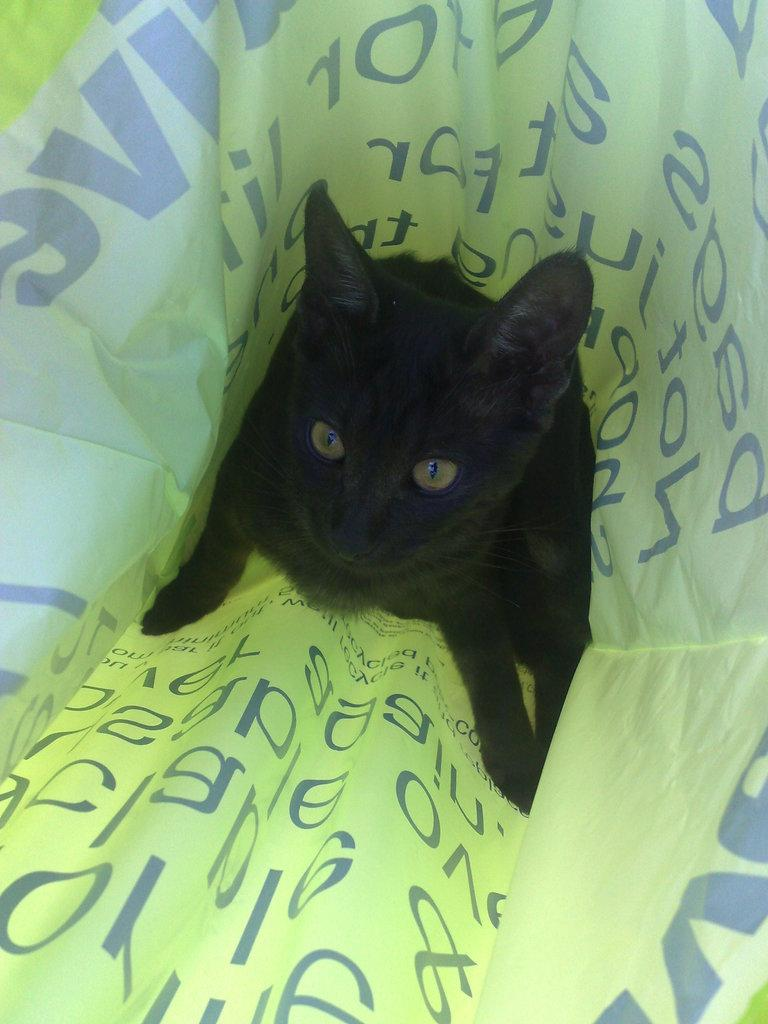What type of animal is in the image? There is a black cat in the image. Where is the cat located in the image? The cat is inside a bag. Are there any giants attempting to prove their existence in the image? There are no giants present in the image, and therefore no such attempt can be observed. 